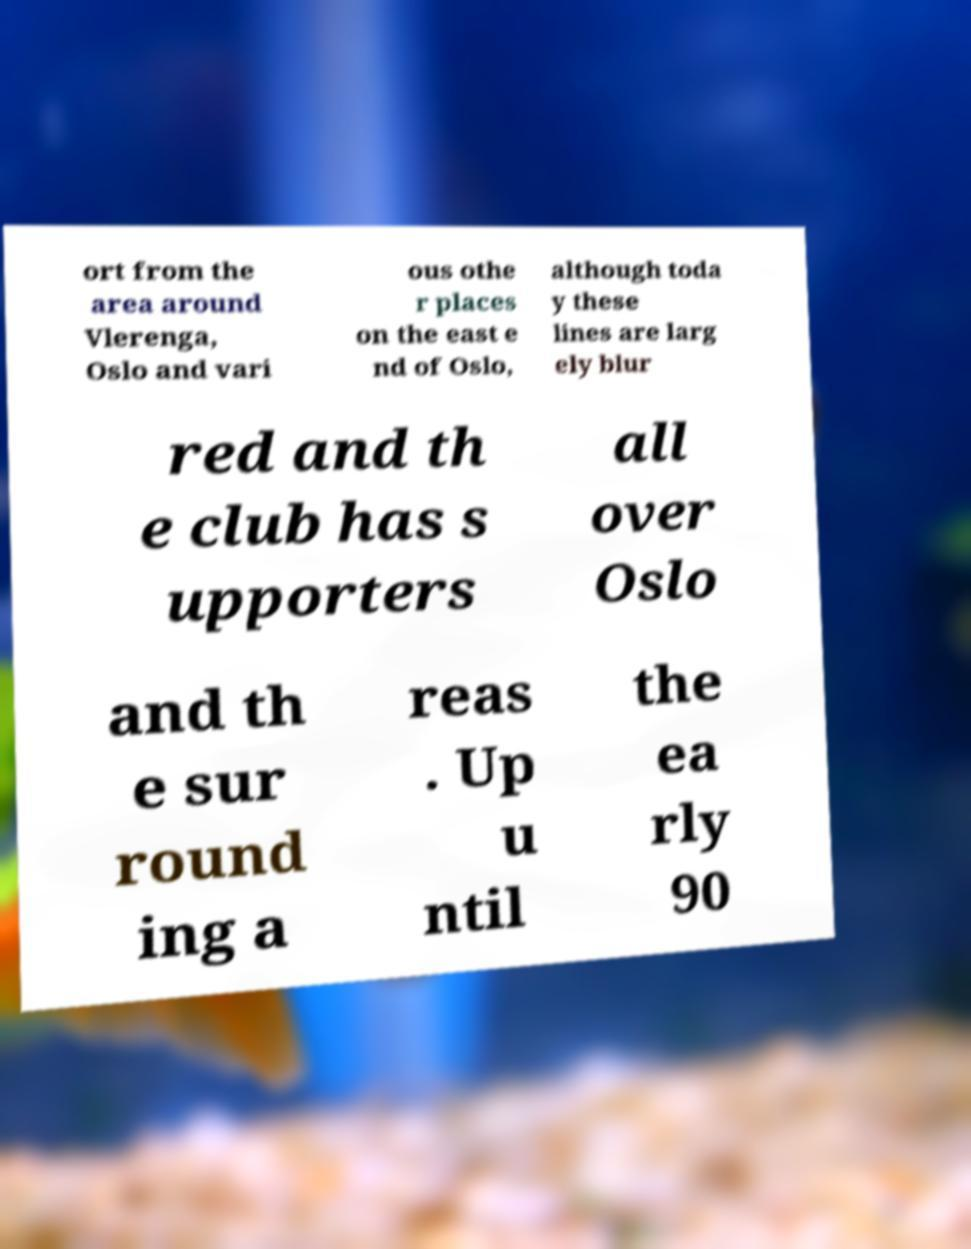Please identify and transcribe the text found in this image. ort from the area around Vlerenga, Oslo and vari ous othe r places on the east e nd of Oslo, although toda y these lines are larg ely blur red and th e club has s upporters all over Oslo and th e sur round ing a reas . Up u ntil the ea rly 90 